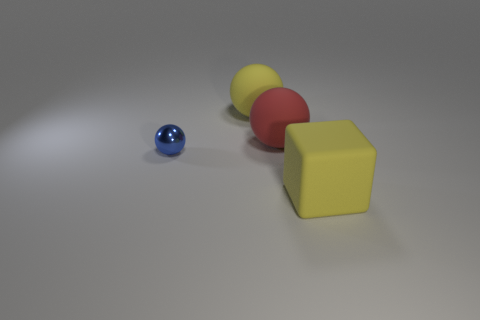Add 1 small matte objects. How many objects exist? 5 Subtract all cubes. How many objects are left? 3 Add 2 big rubber balls. How many big rubber balls are left? 4 Add 1 metal things. How many metal things exist? 2 Subtract 0 purple cylinders. How many objects are left? 4 Subtract all blue shiny things. Subtract all metallic things. How many objects are left? 2 